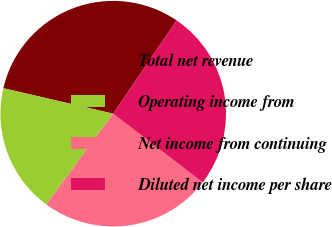<chart> <loc_0><loc_0><loc_500><loc_500><pie_chart><fcel>Total net revenue<fcel>Operating income from<fcel>Net income from continuing<fcel>Diluted net income per share<nl><fcel>30.86%<fcel>18.52%<fcel>24.69%<fcel>25.93%<nl></chart> 